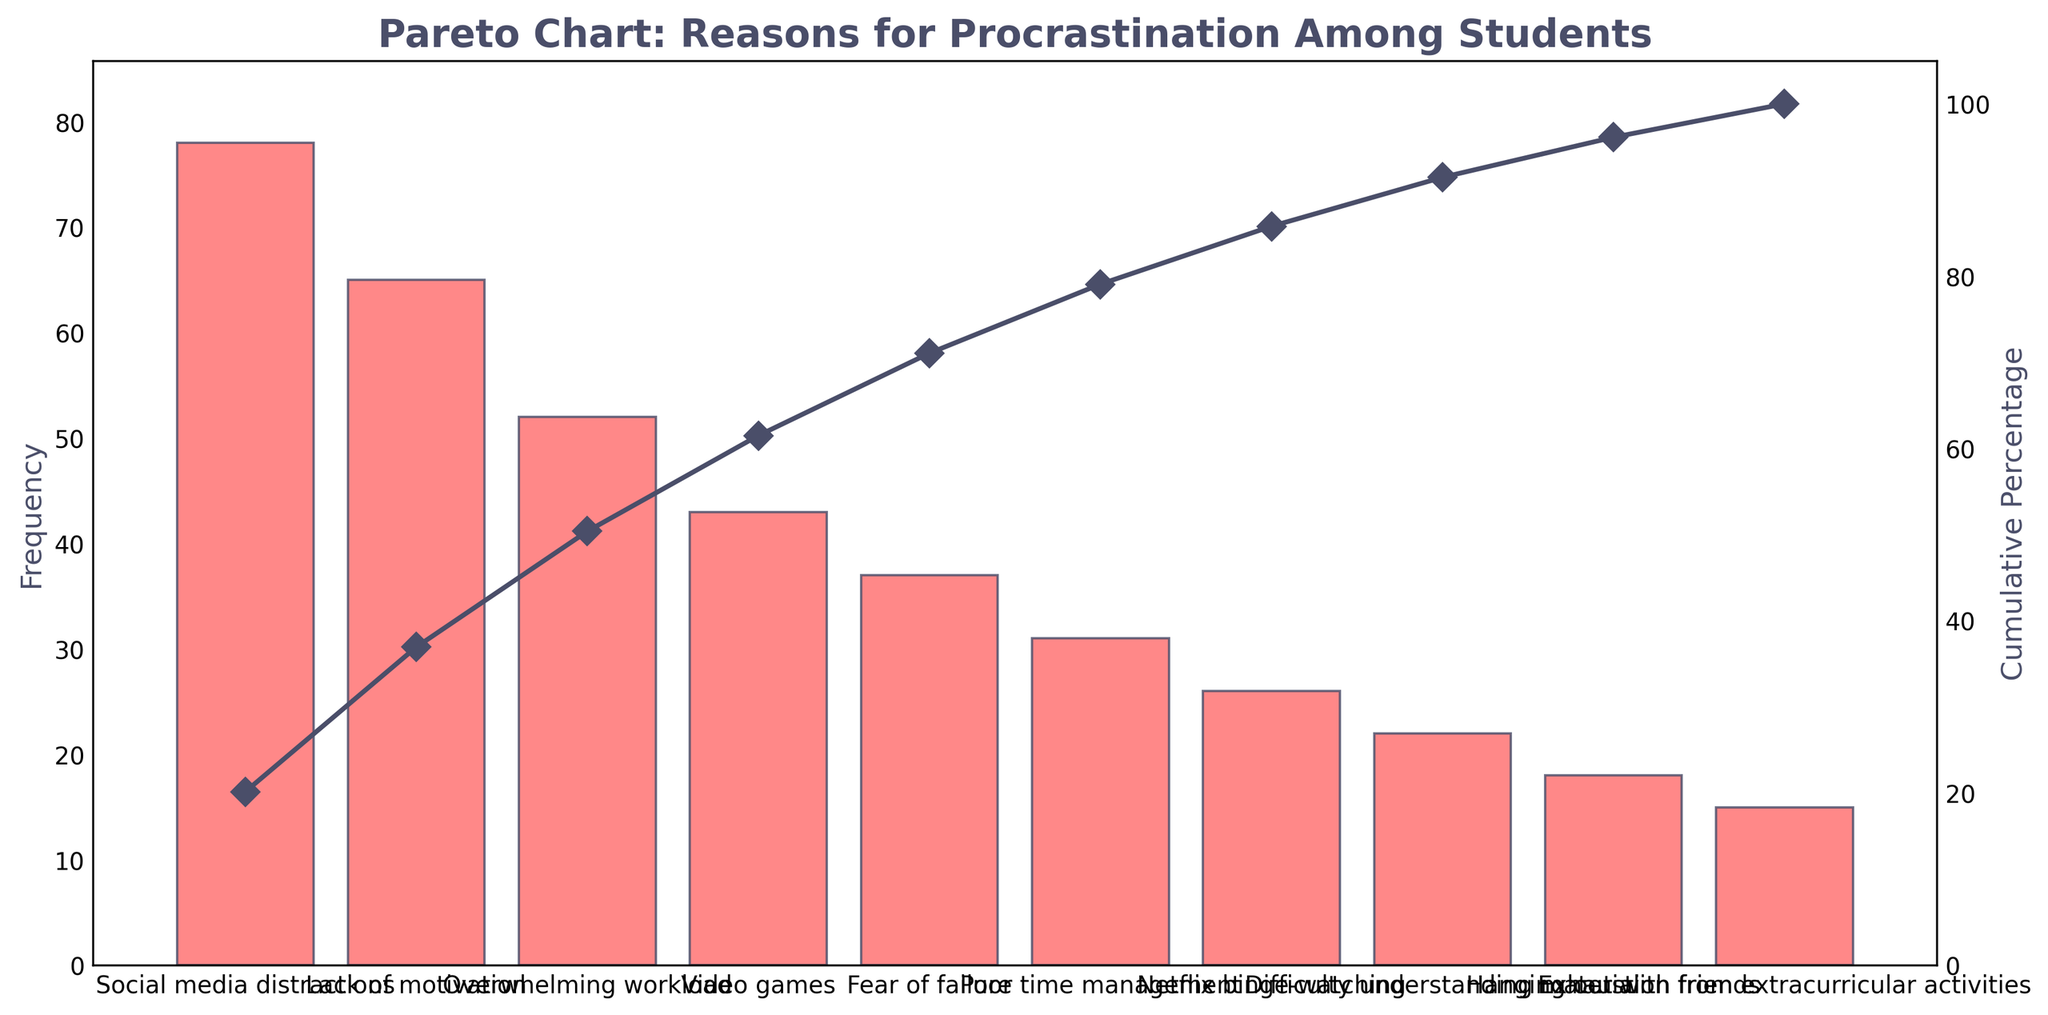What is the title of the figure? The title of the figure is displayed prominently at the top of the chart.
Answer: Pareto Chart: Reasons for Procrastination Among Students How many reasons for procrastination are listed in the figure? Count the total number of distinct reasons displayed on the x-axis of the chart.
Answer: 10 Which reason has the highest frequency? Identify the reason with the tallest bar in the bar plot.
Answer: Social media distractions What is the cumulative percentage for "Lack of motivation"? Locate the point on the line plot above "Lack of motivation" and read the corresponding percentage value.
Answer: 45% By how much does the frequency of "Social media distractions" exceed "Video games"? Subtract the frequency of "Video games" from the frequency of "Social media distractions".
Answer: 35 Which reason has a lower frequency: "Netflix binge-watching" or "Hanging out with friends"? Compare the heights of the bars for "Netflix binge-watching" and "Hanging out with friends".
Answer: Hanging out with friends What is the combined frequency of "Exhaustion from extracurricular activities" and "Hanging out with friends"? Add the frequencies of both reasons: 15 + 18 = 33.
Answer: 33 What is the percentage contribution of "Fear of failure" to the cumulative percentage? Calculate the contribution by dividing the frequency of "Fear of failure" by the total sum of frequencies, then multiply by 100.
Answer: 11% Which reasons contribute to over 80% of the cumulative percentage? Identify the reasons until the line plot reaches just over the 80% mark.
Answer: Social media distractions, Lack of motivation, Overwhelming workload, Video games, Fear of failure, Poor time management What is the approximate cumulative percentage after incorporating the frequency of "Difficulty understanding material"? Read the cumulative percentage value at the point where "Difficulty understanding material" is located on the x-axis.
Answer: 90% 